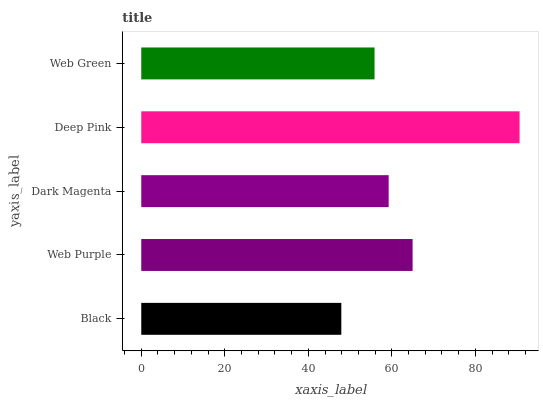Is Black the minimum?
Answer yes or no. Yes. Is Deep Pink the maximum?
Answer yes or no. Yes. Is Web Purple the minimum?
Answer yes or no. No. Is Web Purple the maximum?
Answer yes or no. No. Is Web Purple greater than Black?
Answer yes or no. Yes. Is Black less than Web Purple?
Answer yes or no. Yes. Is Black greater than Web Purple?
Answer yes or no. No. Is Web Purple less than Black?
Answer yes or no. No. Is Dark Magenta the high median?
Answer yes or no. Yes. Is Dark Magenta the low median?
Answer yes or no. Yes. Is Web Green the high median?
Answer yes or no. No. Is Deep Pink the low median?
Answer yes or no. No. 